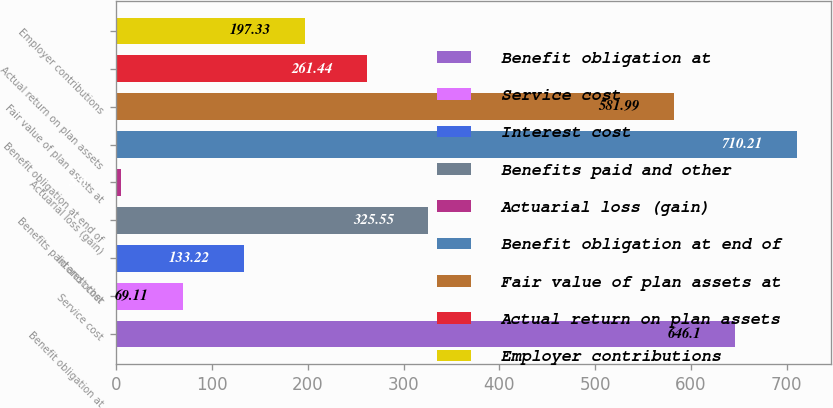<chart> <loc_0><loc_0><loc_500><loc_500><bar_chart><fcel>Benefit obligation at<fcel>Service cost<fcel>Interest cost<fcel>Benefits paid and other<fcel>Actuarial loss (gain)<fcel>Benefit obligation at end of<fcel>Fair value of plan assets at<fcel>Actual return on plan assets<fcel>Employer contributions<nl><fcel>646.1<fcel>69.11<fcel>133.22<fcel>325.55<fcel>5<fcel>710.21<fcel>581.99<fcel>261.44<fcel>197.33<nl></chart> 